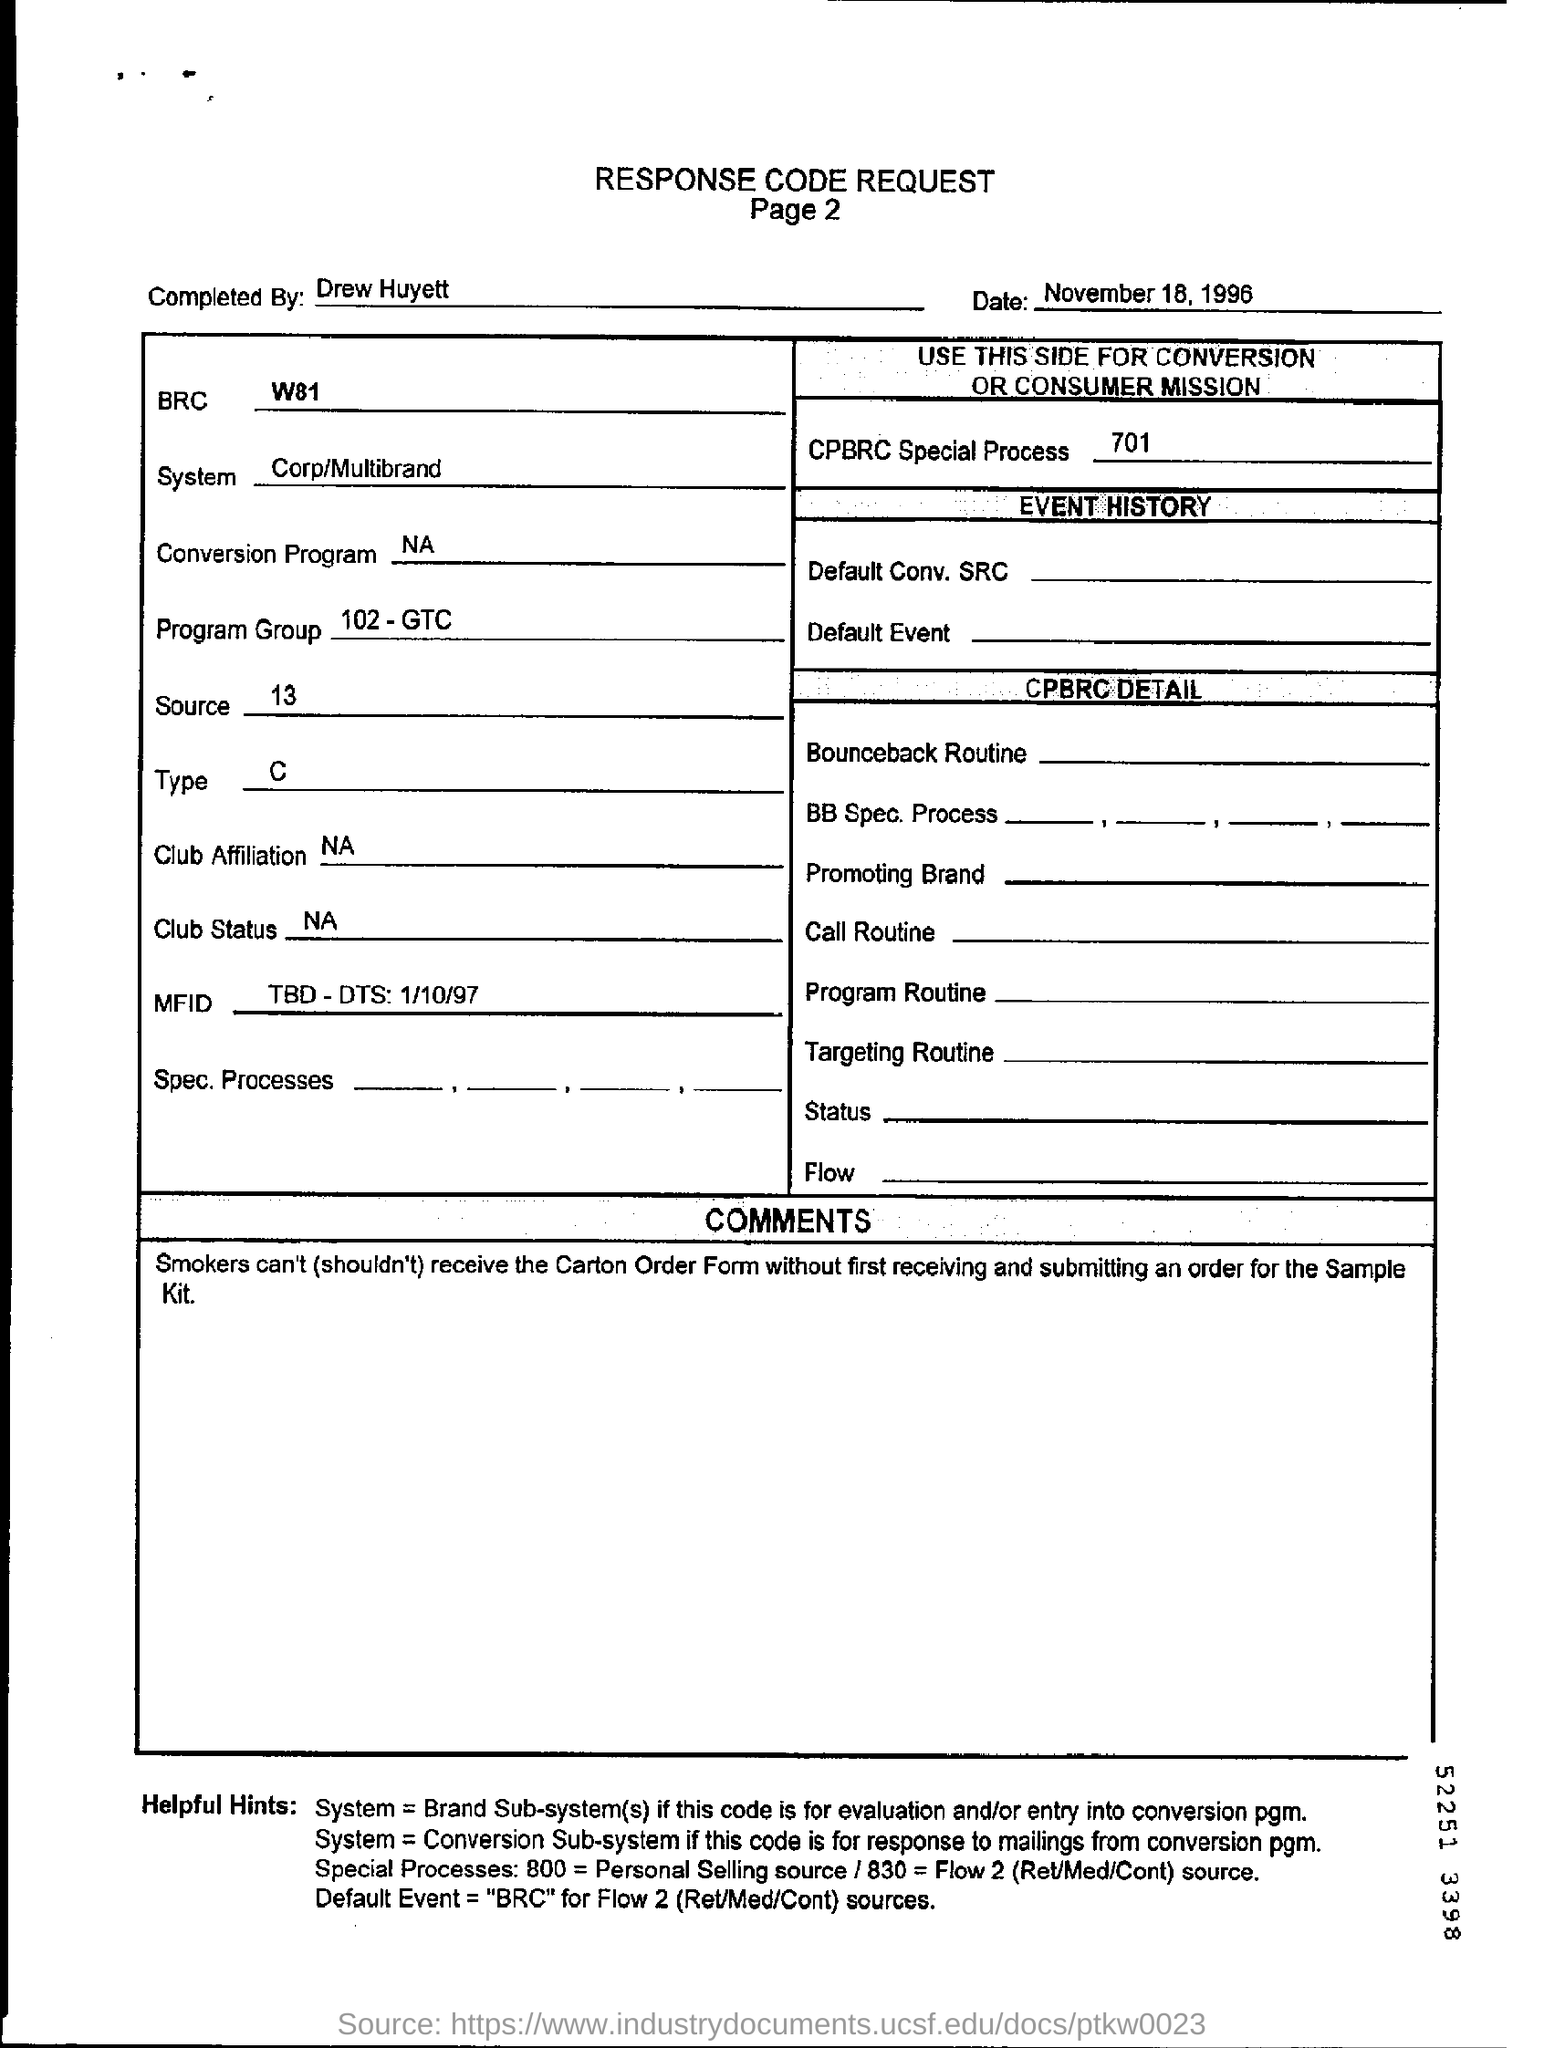Mention a couple of crucial points in this snapshot. The program group mentioned in the response code request is 102-GTC. What is the default event source for Flow 2 BRC? The recipient of the carton order form cannot be smokers. 